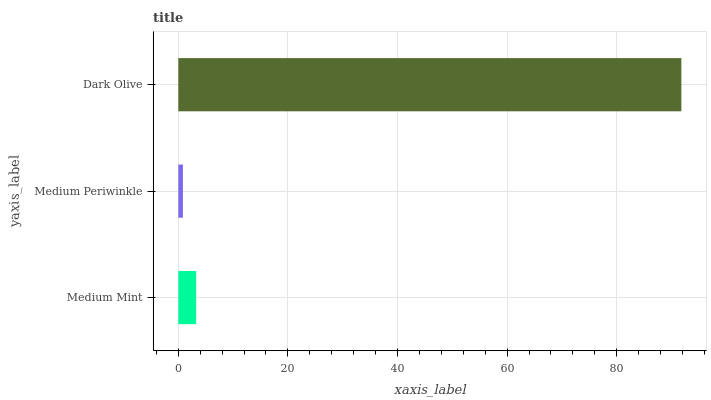Is Medium Periwinkle the minimum?
Answer yes or no. Yes. Is Dark Olive the maximum?
Answer yes or no. Yes. Is Dark Olive the minimum?
Answer yes or no. No. Is Medium Periwinkle the maximum?
Answer yes or no. No. Is Dark Olive greater than Medium Periwinkle?
Answer yes or no. Yes. Is Medium Periwinkle less than Dark Olive?
Answer yes or no. Yes. Is Medium Periwinkle greater than Dark Olive?
Answer yes or no. No. Is Dark Olive less than Medium Periwinkle?
Answer yes or no. No. Is Medium Mint the high median?
Answer yes or no. Yes. Is Medium Mint the low median?
Answer yes or no. Yes. Is Dark Olive the high median?
Answer yes or no. No. Is Medium Periwinkle the low median?
Answer yes or no. No. 